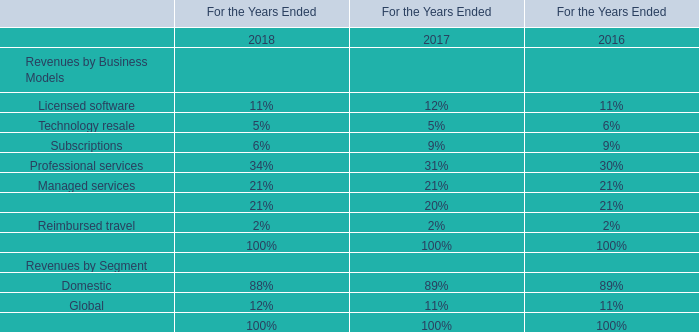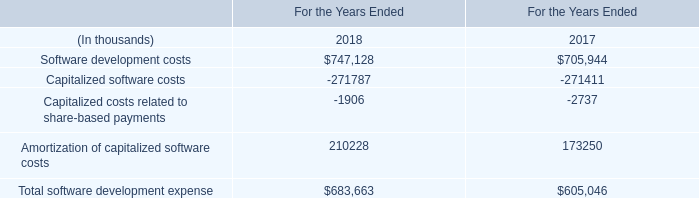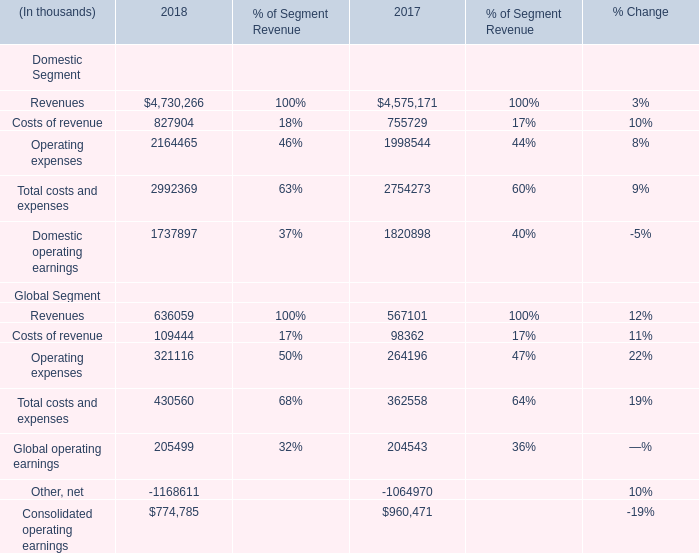what is the ratio of the 2012 contribution to the anticipated employee contributions in 2013 
Computations: (3.6 / 1.5)
Answer: 2.4. 